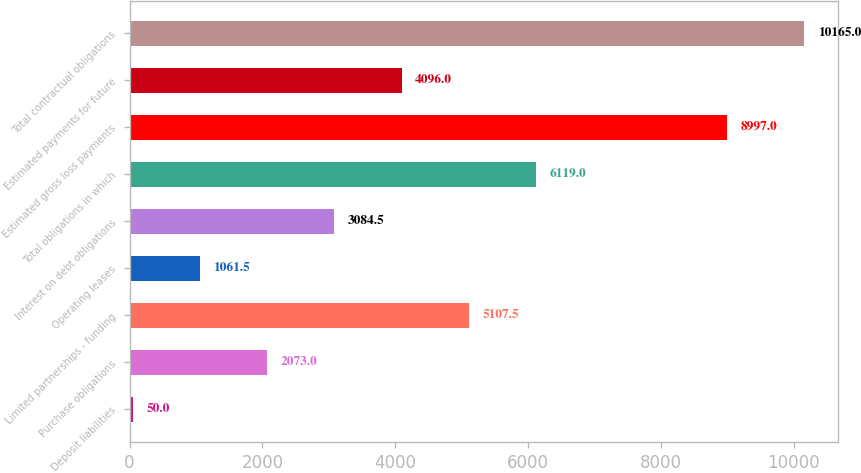Convert chart. <chart><loc_0><loc_0><loc_500><loc_500><bar_chart><fcel>Deposit liabilities<fcel>Purchase obligations<fcel>Limited partnerships - funding<fcel>Operating leases<fcel>Interest on debt obligations<fcel>Total obligations in which<fcel>Estimated gross loss payments<fcel>Estimated payments for future<fcel>Total contractual obligations<nl><fcel>50<fcel>2073<fcel>5107.5<fcel>1061.5<fcel>3084.5<fcel>6119<fcel>8997<fcel>4096<fcel>10165<nl></chart> 